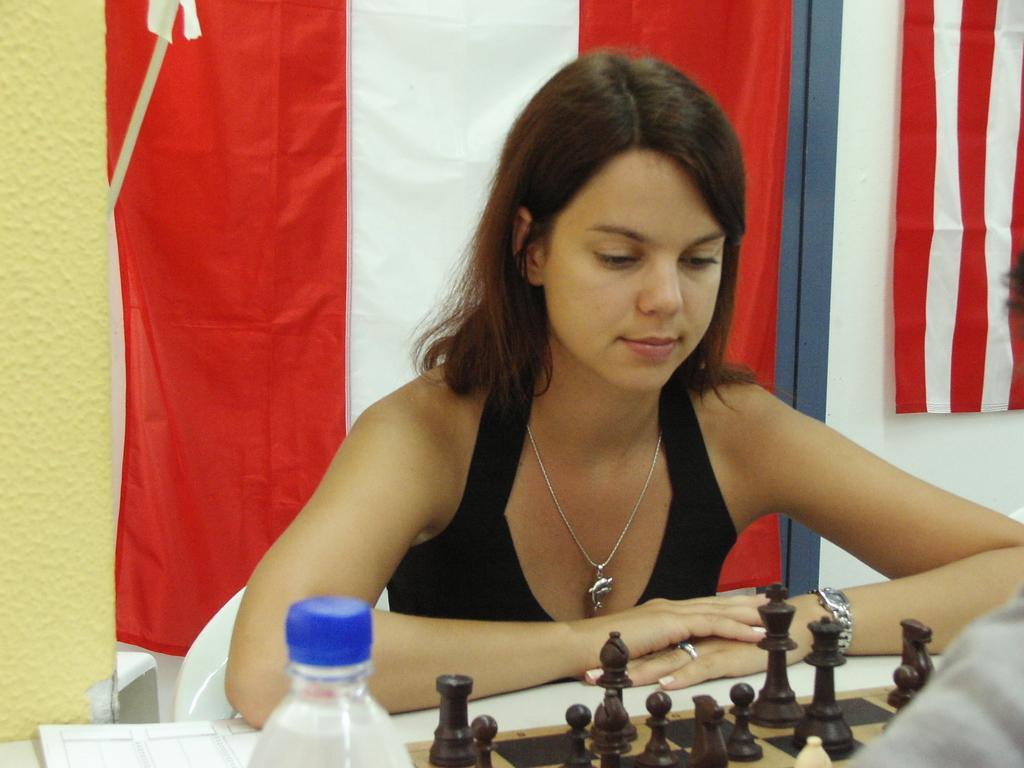Please provide a concise description of this image. In this image there is a woman with black dress sitting behind the table. There is a bottle and chessboard on the table. At the back there is a flag. 